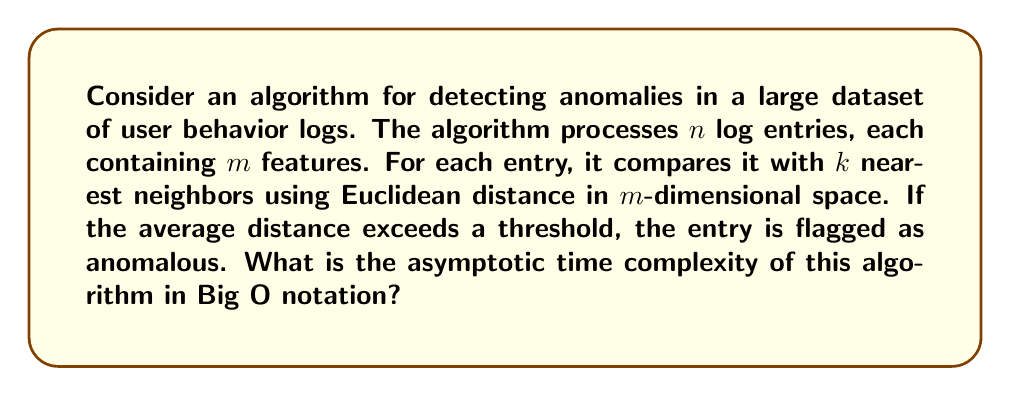Show me your answer to this math problem. Let's break down the algorithm and analyze its time complexity step by step:

1. Processing $n$ log entries:
   This forms the outer loop of our algorithm, contributing a factor of $n$ to the time complexity.

2. For each entry, finding $k$ nearest neighbors:
   a. To find the nearest neighbors, we need to calculate the distance to all other entries.
   b. Calculating Euclidean distance in $m$-dimensional space for one pair of entries:
      $$d = \sqrt{\sum_{i=1}^m (x_i - y_i)^2}$$
      This requires $m$ subtractions, $m$ multiplications, $m-1$ additions, and one square root operation.
      The time complexity for one distance calculation is $O(m)$.
   c. We need to calculate this distance for $n-1$ other entries (all except the current entry).
   d. After calculating distances, we need to find the $k$ smallest distances. This can be done using a priority queue in $O(n \log k)$ time.

3. Calculating the average distance:
   This requires summing $k$ distances and dividing by $k$, which is $O(k)$.

4. Comparing with a threshold:
   This is a constant time operation, $O(1)$.

Putting it all together:
- The outer loop runs $n$ times.
- For each iteration, we perform $n-1$ distance calculations of $O(m)$ each, then a $O(n \log k)$ operation to find $k$ nearest neighbors, and finally $O(k)$ operations.

The total time complexity is:
$$O(n \cdot (n \cdot m + n \log k + k))$$

Simplifying:
$$O(n^2m + n^2 \log k + nk)$$

Since $k$ is typically much smaller than $n$, and $m$ is usually considered a constant in big data scenarios, we can simplify this to:

$$O(n^2)$$

This quadratic time complexity is due to the pairwise distance calculations between all entries.
Answer: $O(n^2)$ 